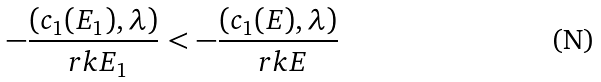<formula> <loc_0><loc_0><loc_500><loc_500>- \frac { ( c _ { 1 } ( E _ { 1 } ) , \lambda ) } { \ r k E _ { 1 } } < - \frac { ( c _ { 1 } ( E ) , \lambda ) } { \ r k E }</formula> 